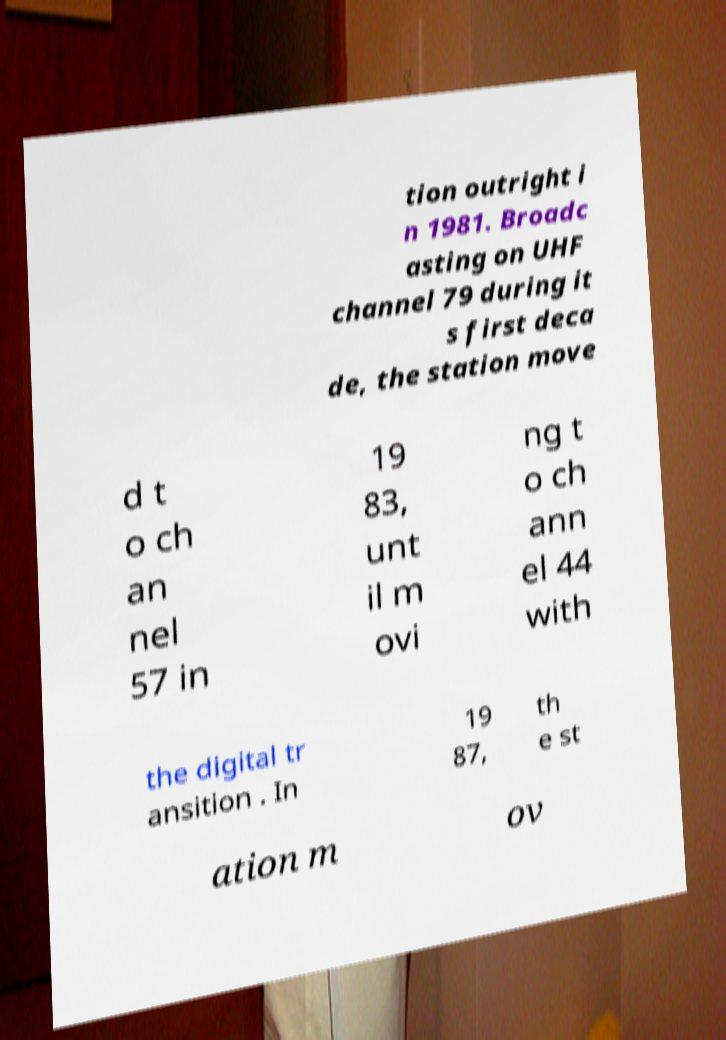Could you assist in decoding the text presented in this image and type it out clearly? tion outright i n 1981. Broadc asting on UHF channel 79 during it s first deca de, the station move d t o ch an nel 57 in 19 83, unt il m ovi ng t o ch ann el 44 with the digital tr ansition . In 19 87, th e st ation m ov 